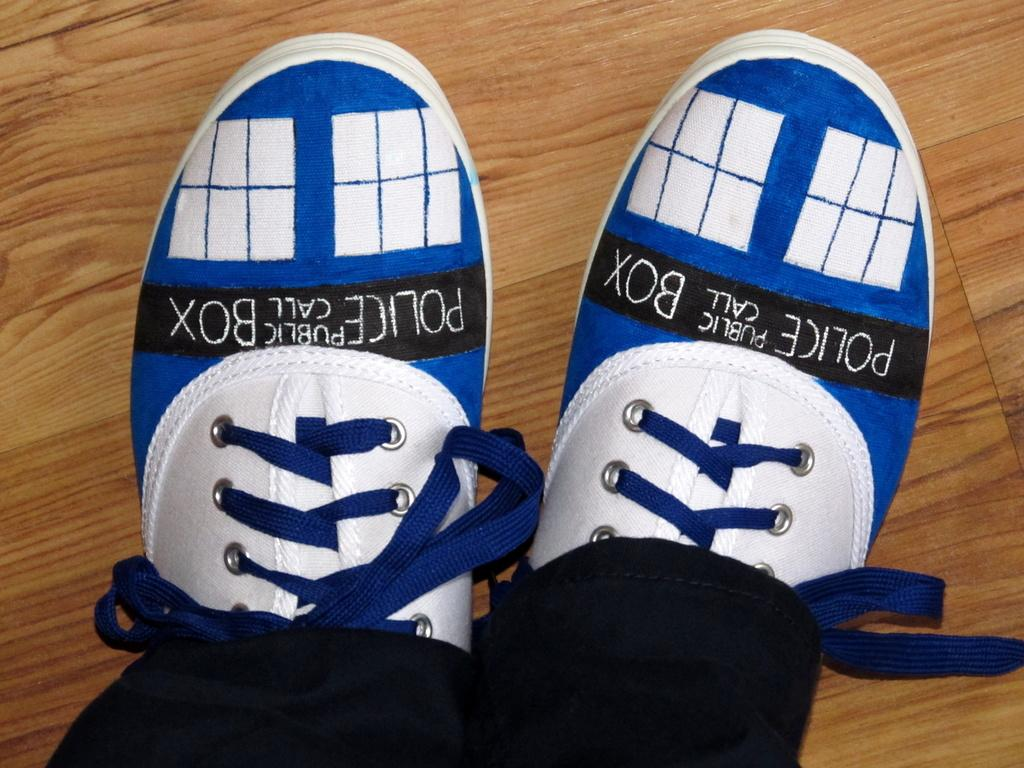What body part is visible in the image? There are legs visible in the image. To whom do the legs belong? The legs belong to a person. What type of footwear is the person wearing? The person is wearing shoes. What type of surface can be seen in the image? There is a wooden surface in the image. What story is the person telling while standing on the wooden surface? There is no indication in the image that the person is telling a story. 